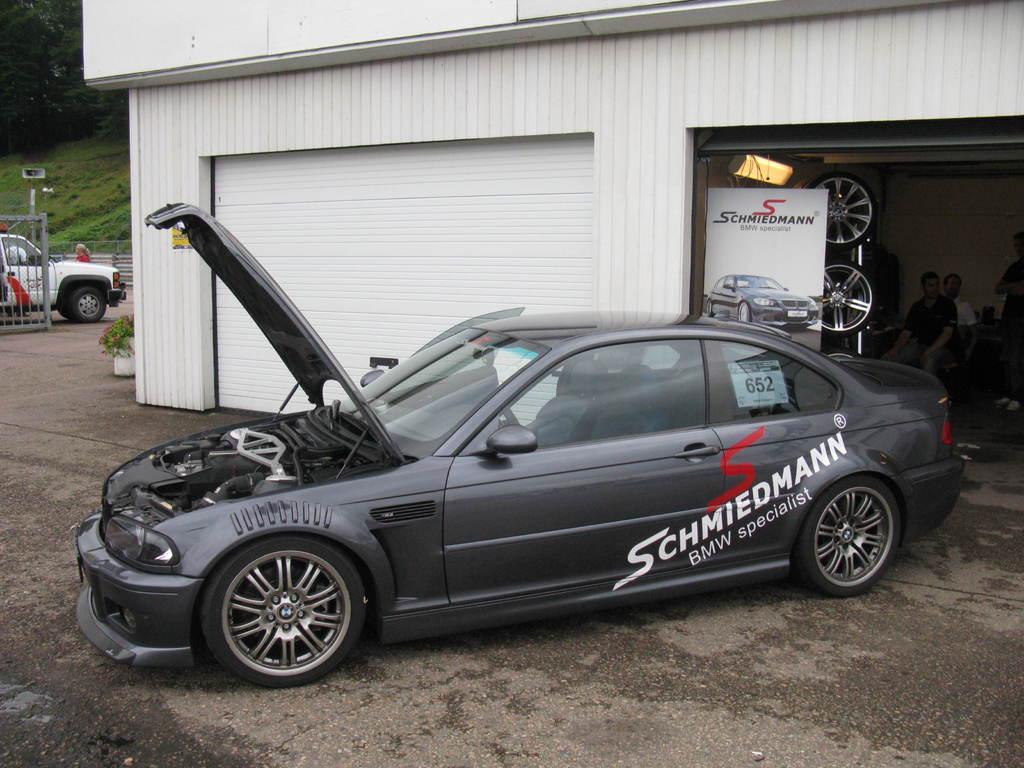Can you describe this image briefly? In this picture, there is a car in the center which is in grey in color. It is facing towards the left. Towards right, there is a building with two roller shutters. In the shutter, there are people, tiers and a board. Towards the left, there is a gross, vehicle and trees. 